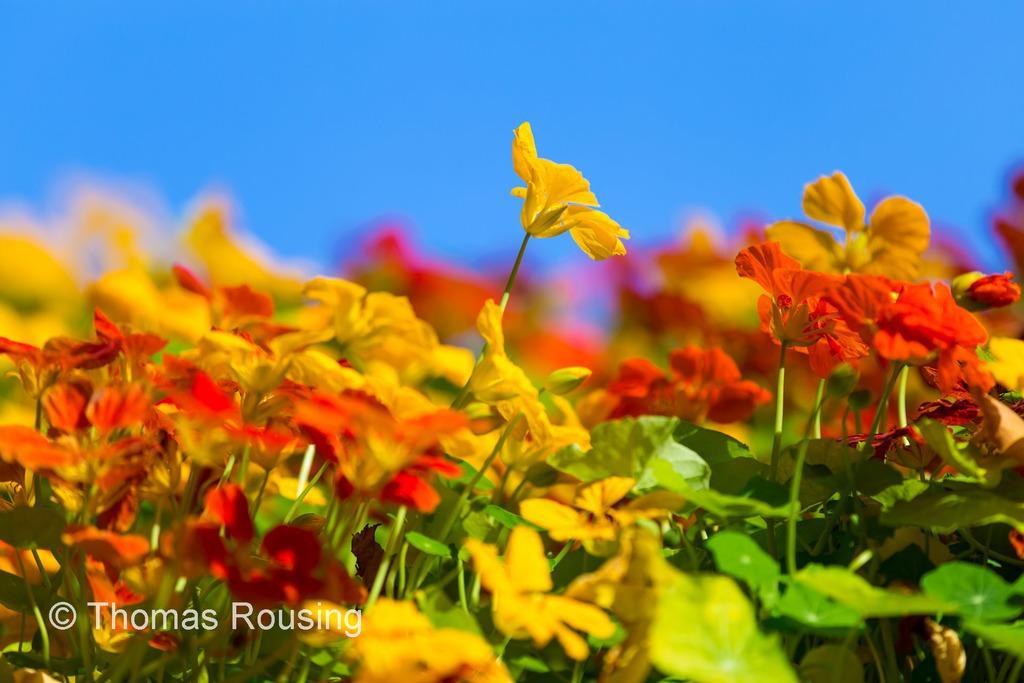Could you give a brief overview of what you see in this image? In this picture there are flowers on the plants and the flowers are in yellow and in red colors. At the top there is sky. At the bottom left there is a text. 